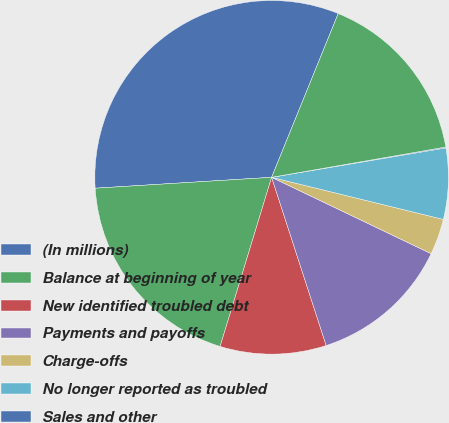Convert chart. <chart><loc_0><loc_0><loc_500><loc_500><pie_chart><fcel>(In millions)<fcel>Balance at beginning of year<fcel>New identified troubled debt<fcel>Payments and payoffs<fcel>Charge-offs<fcel>No longer reported as troubled<fcel>Sales and other<fcel>Balance at end of year<nl><fcel>32.13%<fcel>19.31%<fcel>9.7%<fcel>12.9%<fcel>3.28%<fcel>6.49%<fcel>0.08%<fcel>16.11%<nl></chart> 